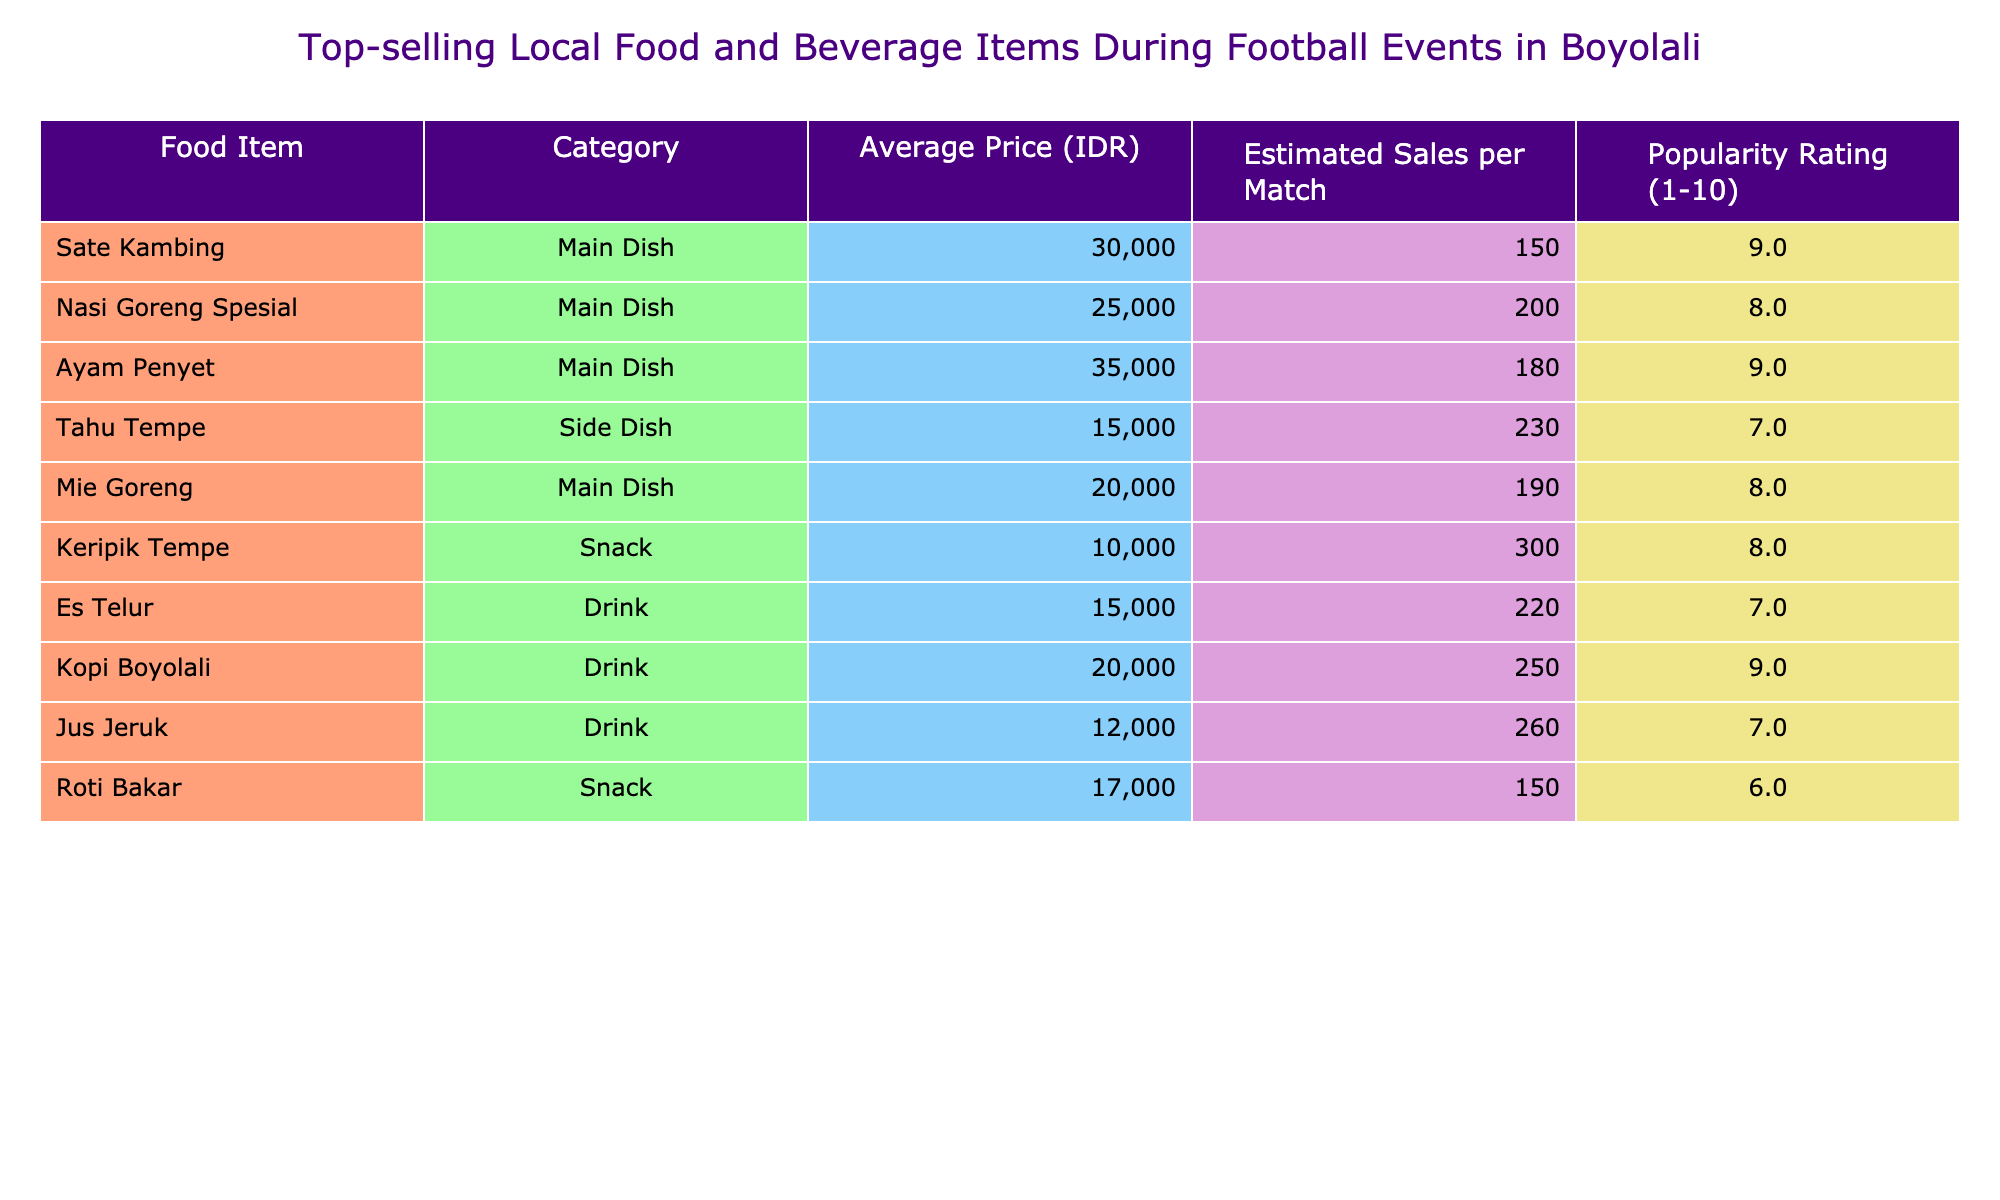What is the most popular food item during football events? The popularity rating for each food item shows that "Sate Kambing" and "Ayam Penyet" have the highest rating of 9.
Answer: Sate Kambing and Ayam Penyet What is the average price of drinks sold during football events? The drinks listed are Es Telur (15,000 IDR), Kopi Boyolali (20,000 IDR), and Jus Jeruk (12,000 IDR). The average price is calculated as (15,000 + 20,000 + 12,000) / 3 = 15,666.67 IDR.
Answer: 15,666.67 IDR Which snack has the highest estimated sales per match? By comparing the estimated sales of snacks, "Keripik Tempe" has the highest estimated sales with 300 units.
Answer: Keripik Tempe How much more is the average price of the main dish compared to the average price of side dishes? Main dishes average: (30,000 + 25,000 + 35,000 + 20,000) / 4 = 27,500 IDR. Side dishes average: 15,000 IDR. The difference is 27,500 - 15,000 = 12,500 IDR.
Answer: 12,500 IDR Is "Nasi Goreng Spesial" more popular than "Tahu Tempe"? The popularity rating for Nasi Goreng Spesial is 8, while Tahu Tempe has a rating of 7. Since 8 is greater than 7, Nasi Goreng Spesial is more popular.
Answer: Yes What is the total estimated sales for all food items during a match? Total estimated sales are calculated by summing the estimated sales per match: 150 + 200 + 180 + 230 + 190 + 300 = 1,450 units sold.
Answer: 1,450 units Which beverage has both the highest estimated sales and popularity rating? Kopi Boyolali has the highest estimated sales (250) and a popularity rating of 9. No other beverage matches or exceeds both of these figures.
Answer: Kopi Boyolali If you combine the sales of "Ayam Penyet" and "Nasi Goreng Spesial," how many units can be expected to be sold? Ayam Penyet sales are 180 units and Nasi Goreng Spesial sales are 200, adding these gives 180 + 200 = 380 units.
Answer: 380 units 